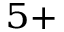Convert formula to latex. <formula><loc_0><loc_0><loc_500><loc_500>^ { 5 + }</formula> 